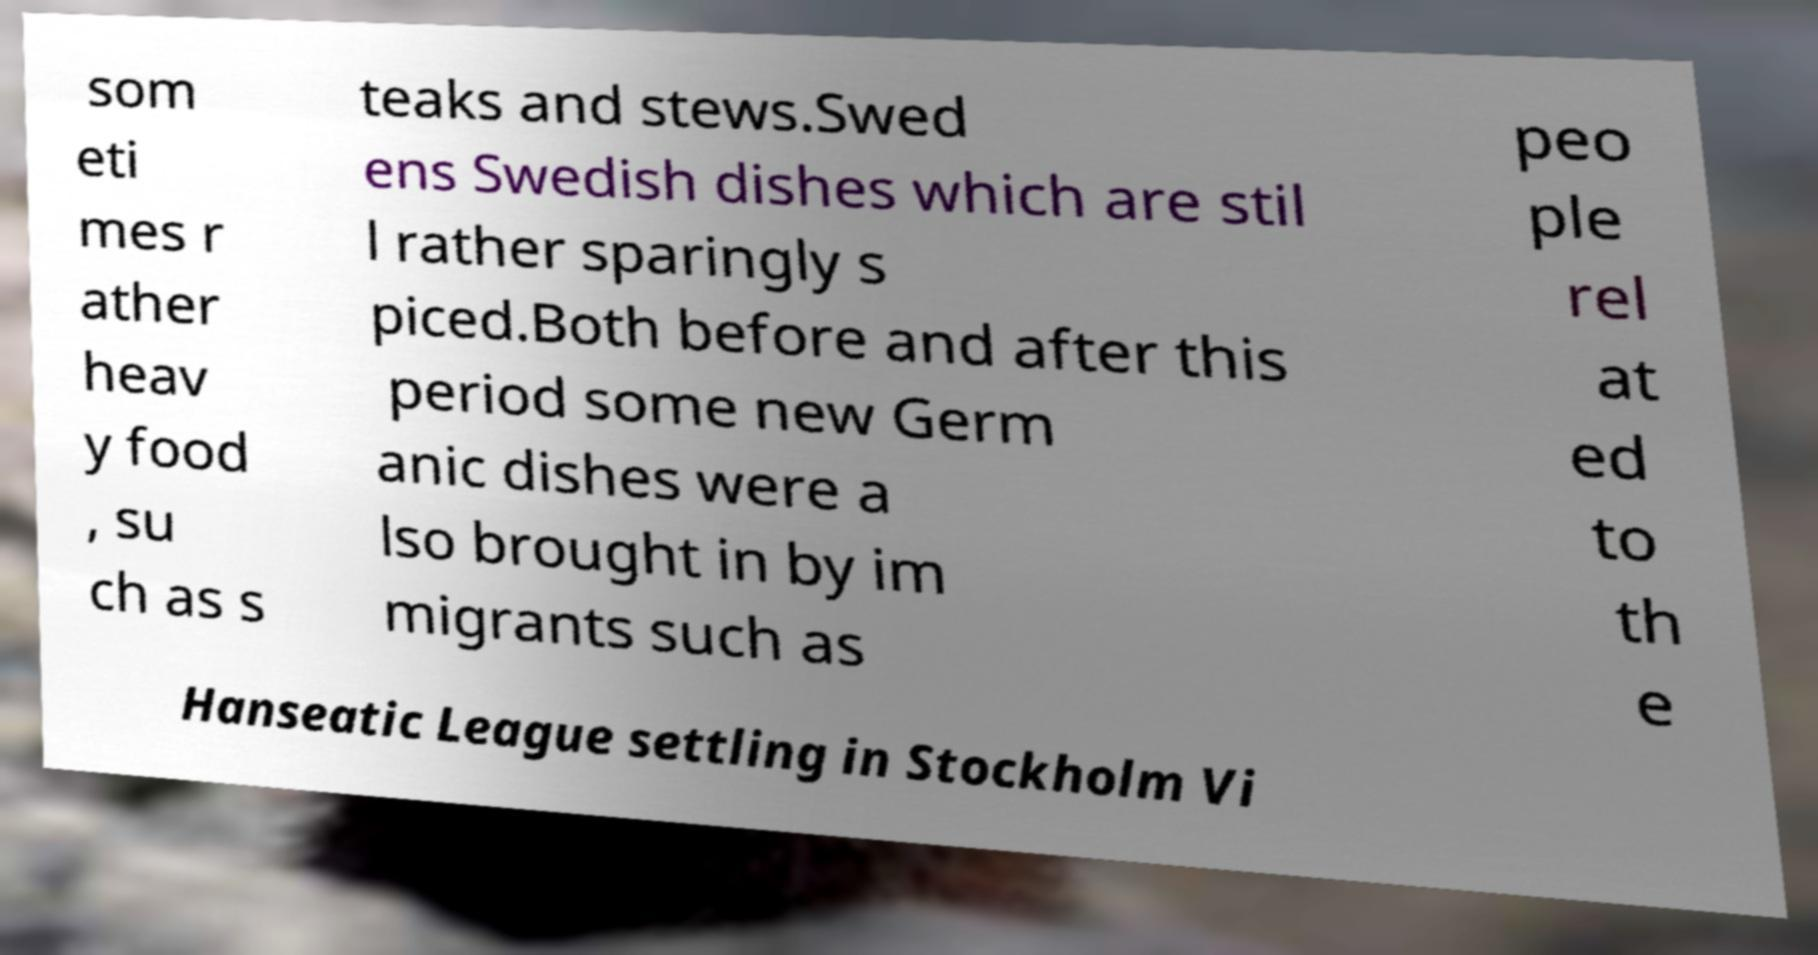For documentation purposes, I need the text within this image transcribed. Could you provide that? som eti mes r ather heav y food , su ch as s teaks and stews.Swed ens Swedish dishes which are stil l rather sparingly s piced.Both before and after this period some new Germ anic dishes were a lso brought in by im migrants such as peo ple rel at ed to th e Hanseatic League settling in Stockholm Vi 